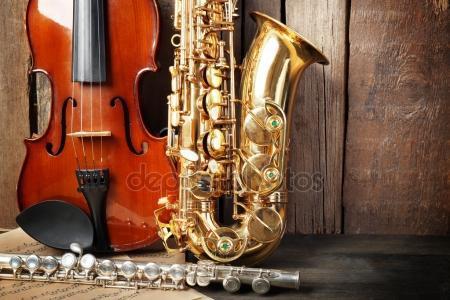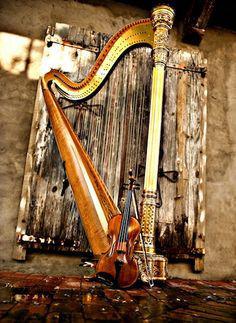The first image is the image on the left, the second image is the image on the right. Analyze the images presented: Is the assertion "The right image contains a violin, sax and flute." valid? Answer yes or no. No. The first image is the image on the left, the second image is the image on the right. Considering the images on both sides, is "Only a single saxophone in each picture." valid? Answer yes or no. No. 